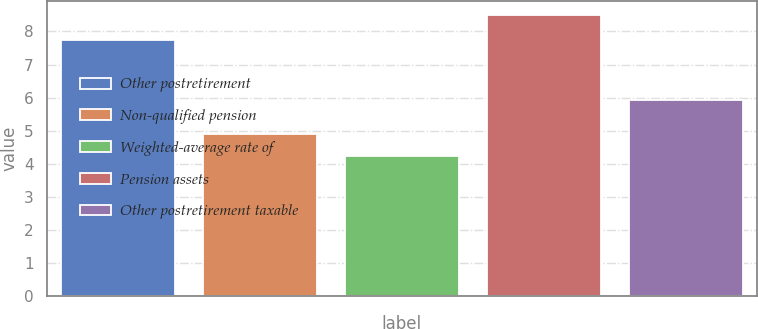<chart> <loc_0><loc_0><loc_500><loc_500><bar_chart><fcel>Other postretirement<fcel>Non-qualified pension<fcel>Weighted-average rate of<fcel>Pension assets<fcel>Other postretirement taxable<nl><fcel>7.75<fcel>4.9<fcel>4.23<fcel>8.5<fcel>5.93<nl></chart> 